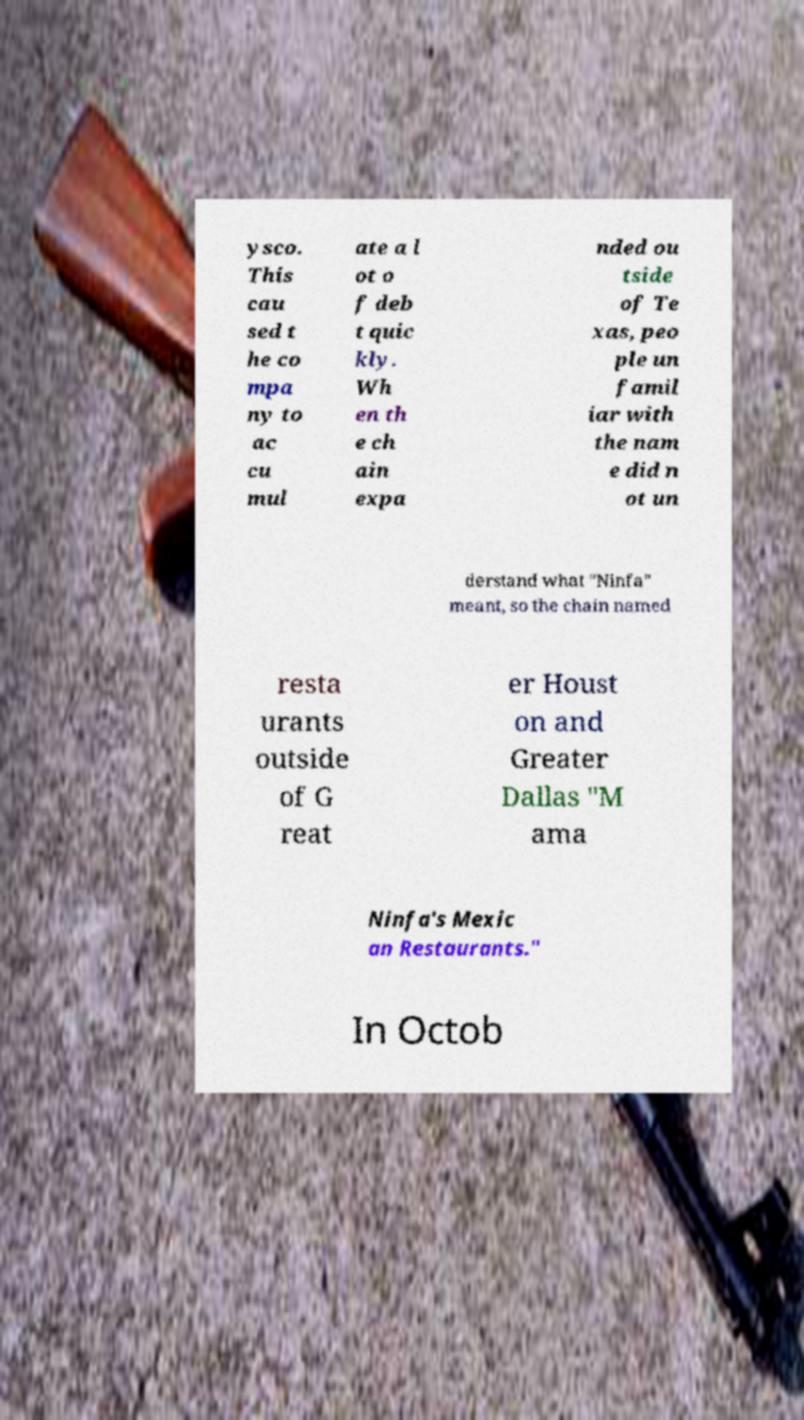Please read and relay the text visible in this image. What does it say? ysco. This cau sed t he co mpa ny to ac cu mul ate a l ot o f deb t quic kly. Wh en th e ch ain expa nded ou tside of Te xas, peo ple un famil iar with the nam e did n ot un derstand what "Ninfa" meant, so the chain named resta urants outside of G reat er Houst on and Greater Dallas "M ama Ninfa's Mexic an Restaurants." In Octob 